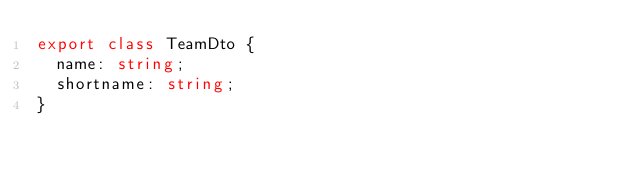<code> <loc_0><loc_0><loc_500><loc_500><_TypeScript_>export class TeamDto {
  name: string;
  shortname: string;
}
</code> 